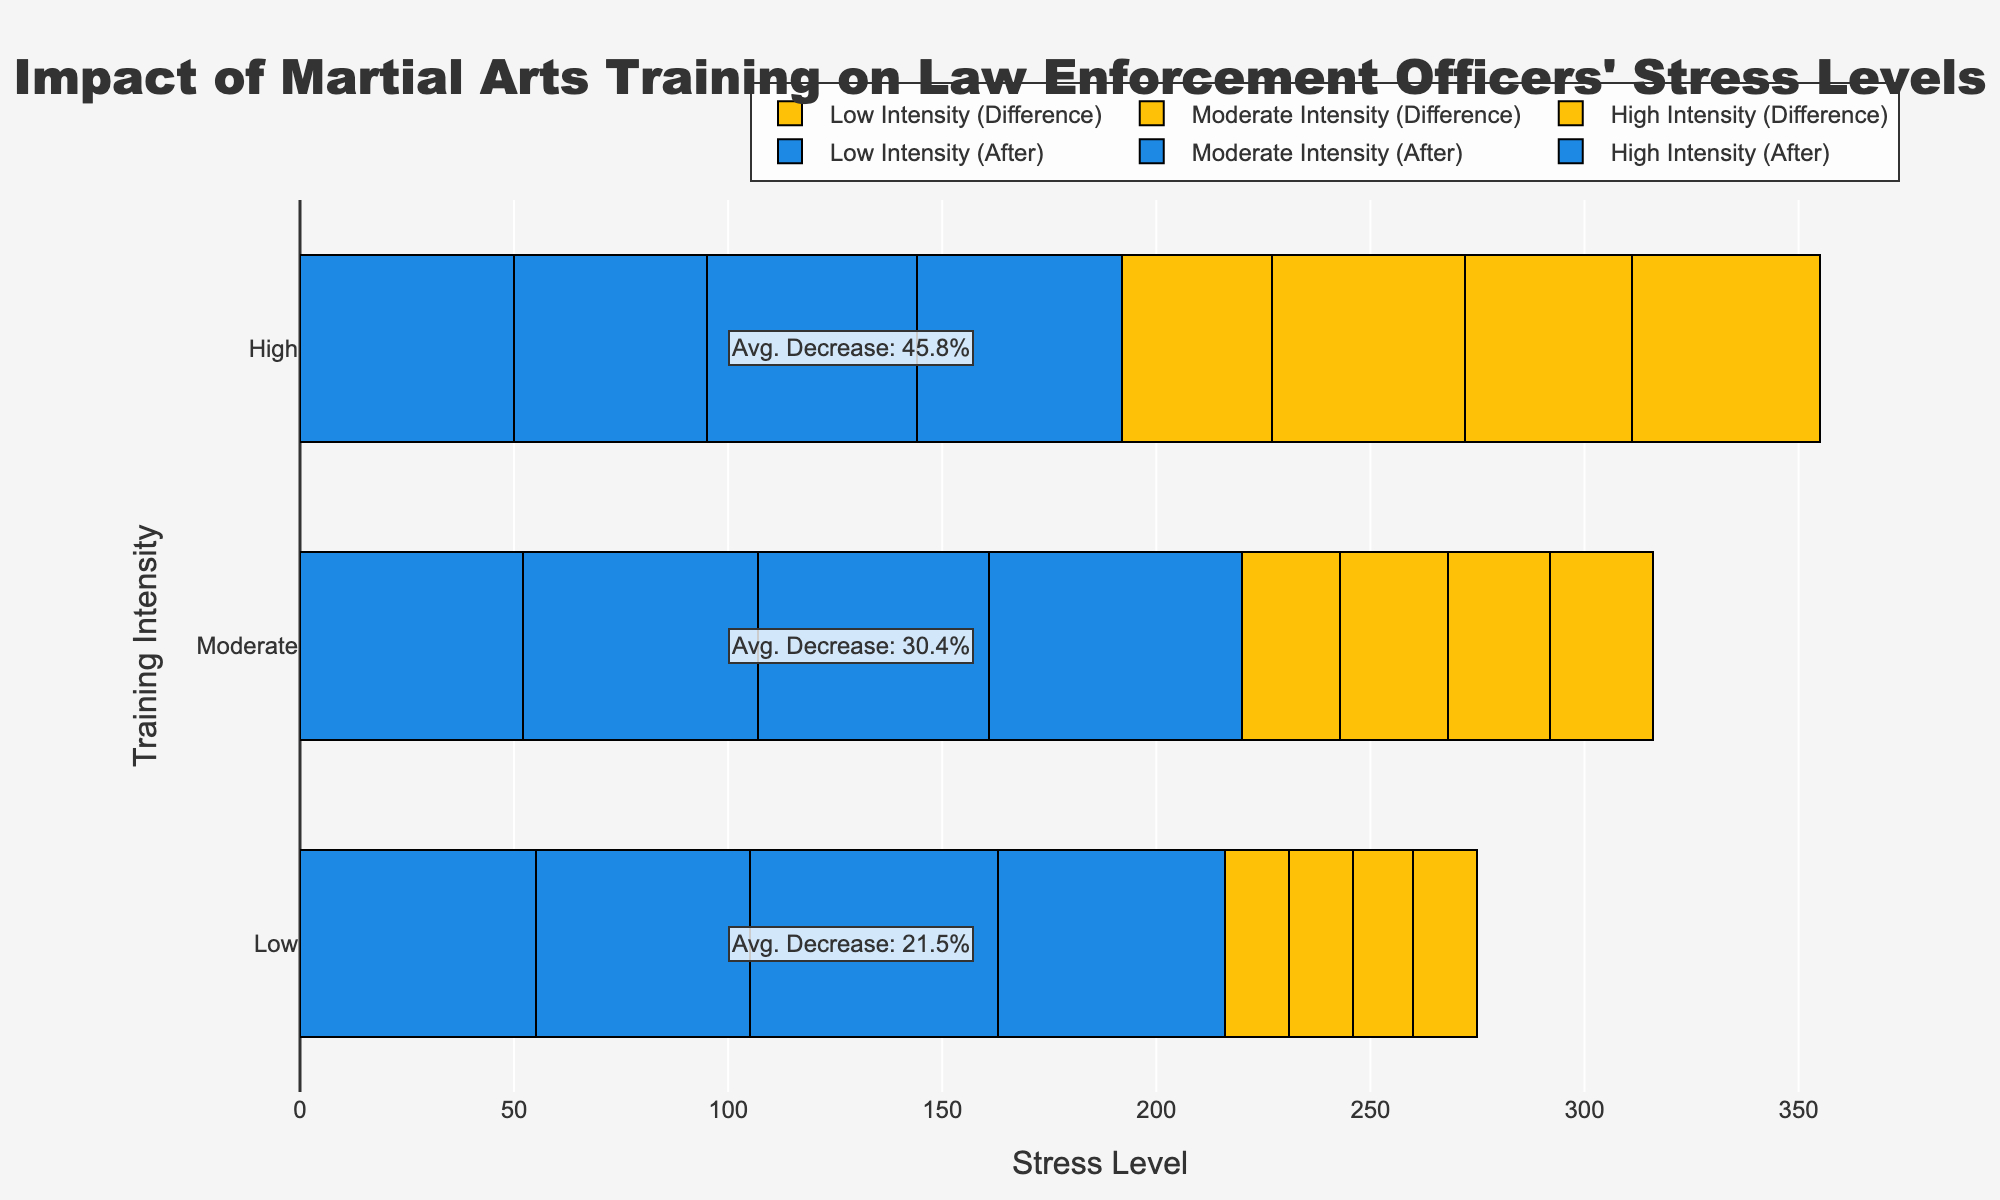What's the average decrease percentage for each training intensity? The annotations in the figure show the average decrease percentage for each training intensity: for Low intensity, it's stated, for Moderate intensity, and for High intensity as well.
Answer: Low: 21.5%, Moderate: 30.4%, High: 45.8% Which training intensity had the greatest reduction in stress levels after martial arts training? By comparing the lengths of the yellow difference bars representing the stress difference, High intensity has the longest bars, indicating the greatest reduction.
Answer: High intensity What were the stress levels before and after training for the Moderate intensity group? Check the moderate intensity section of the graph. The blue bars represent stress levels after training, and the combined lengths of both bars (blue + yellow) represent the stress levels before training.
Answer: Before: 75, 80, 78, 83; After: 52, 55, 54, 59 How does the decrease in stress levels from Low to High training intensity compare visually? Visually, the yellow difference bars are shortest in the Low intensity group and longest in the High intensity group, indicating an increasing stress level reduction from Low to High intensity.
Answer: Stress reduction increases from Low to High intensity What is the average stress level after training for each intensity group? Use the blue bars for each training intensity group and calculate their averages. For Low: (55 + 50 + 58 + 53) / 4, for Moderate: (52 + 55 + 54 + 59) / 4, for High: (50 + 45 + 49 + 48) / 4.
Answer: Low: 54, Moderate: 55, High: 48 Which visualization technique is used to show the reduction in stress levels in the chart? The chart uses a diverging stacked bar approach, where blue bars represent the stress level after training and yellow bars represent the reduction in stress.
Answer: Diverging stacked bar chart Is there a consistent decrease in stress levels across all training intensities? By observing the chart, each training intensity section shows consistent yellow bars indicating a decrease; however, the lengths of the bars and hence, the reduction vary.
Answer: Yes, but the extent varies Which training intensity group has the most significant variation in stress reduction percentages? Look at the yellow bars' lengths representing the stress difference for each intensity group to measure variation visually. High intensity shows the most varied lengths.
Answer: High intensity 